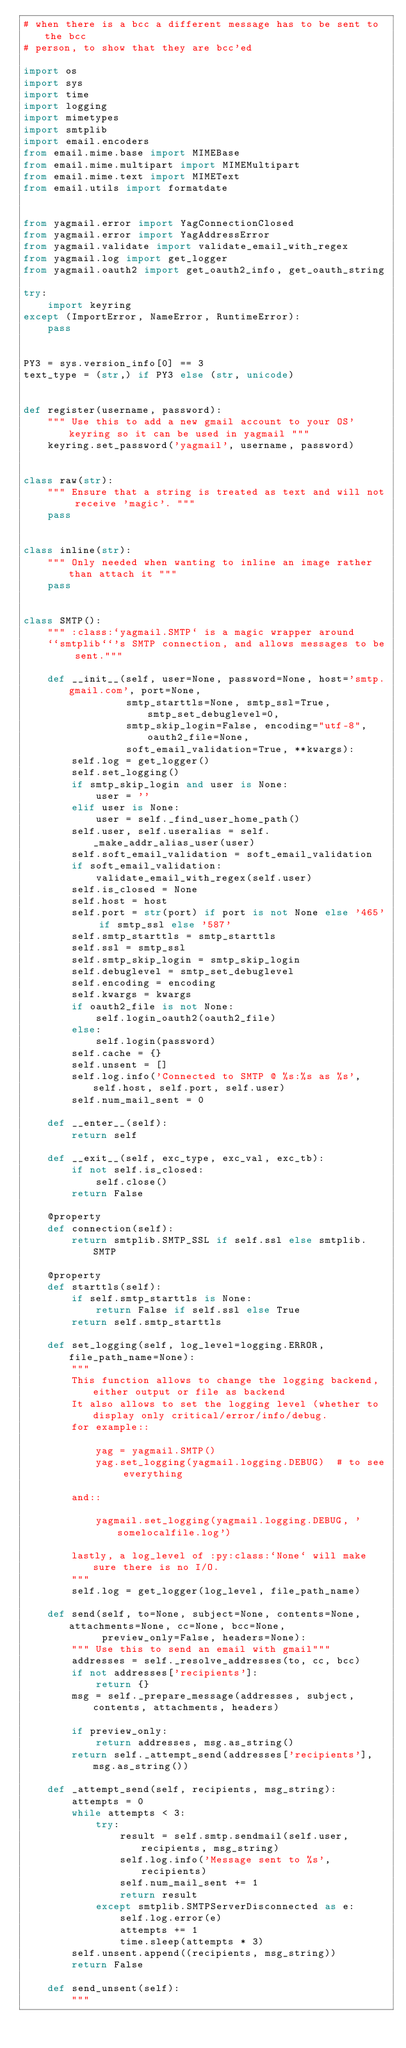Convert code to text. <code><loc_0><loc_0><loc_500><loc_500><_Python_># when there is a bcc a different message has to be sent to the bcc
# person, to show that they are bcc'ed

import os
import sys
import time
import logging
import mimetypes
import smtplib
import email.encoders
from email.mime.base import MIMEBase
from email.mime.multipart import MIMEMultipart
from email.mime.text import MIMEText
from email.utils import formatdate


from yagmail.error import YagConnectionClosed
from yagmail.error import YagAddressError
from yagmail.validate import validate_email_with_regex
from yagmail.log import get_logger
from yagmail.oauth2 import get_oauth2_info, get_oauth_string

try:
    import keyring
except (ImportError, NameError, RuntimeError):
    pass


PY3 = sys.version_info[0] == 3
text_type = (str,) if PY3 else (str, unicode)


def register(username, password):
    """ Use this to add a new gmail account to your OS' keyring so it can be used in yagmail """
    keyring.set_password('yagmail', username, password)


class raw(str):
    """ Ensure that a string is treated as text and will not receive 'magic'. """
    pass


class inline(str):
    """ Only needed when wanting to inline an image rather than attach it """
    pass


class SMTP():
    """ :class:`yagmail.SMTP` is a magic wrapper around
    ``smtplib``'s SMTP connection, and allows messages to be sent."""

    def __init__(self, user=None, password=None, host='smtp.gmail.com', port=None,
                 smtp_starttls=None, smtp_ssl=True, smtp_set_debuglevel=0,
                 smtp_skip_login=False, encoding="utf-8", oauth2_file=None,
                 soft_email_validation=True, **kwargs):
        self.log = get_logger()
        self.set_logging()
        if smtp_skip_login and user is None:
            user = ''
        elif user is None:
            user = self._find_user_home_path()
        self.user, self.useralias = self._make_addr_alias_user(user)
        self.soft_email_validation = soft_email_validation
        if soft_email_validation:
            validate_email_with_regex(self.user)
        self.is_closed = None
        self.host = host
        self.port = str(port) if port is not None else '465' if smtp_ssl else '587'
        self.smtp_starttls = smtp_starttls
        self.ssl = smtp_ssl
        self.smtp_skip_login = smtp_skip_login
        self.debuglevel = smtp_set_debuglevel
        self.encoding = encoding
        self.kwargs = kwargs
        if oauth2_file is not None:
            self.login_oauth2(oauth2_file)
        else:
            self.login(password)
        self.cache = {}
        self.unsent = []
        self.log.info('Connected to SMTP @ %s:%s as %s', self.host, self.port, self.user)
        self.num_mail_sent = 0

    def __enter__(self):
        return self

    def __exit__(self, exc_type, exc_val, exc_tb):
        if not self.is_closed:
            self.close()
        return False

    @property
    def connection(self):
        return smtplib.SMTP_SSL if self.ssl else smtplib.SMTP

    @property
    def starttls(self):
        if self.smtp_starttls is None:
            return False if self.ssl else True
        return self.smtp_starttls

    def set_logging(self, log_level=logging.ERROR, file_path_name=None):
        """
        This function allows to change the logging backend, either output or file as backend
        It also allows to set the logging level (whether to display only critical/error/info/debug.
        for example::

            yag = yagmail.SMTP()
            yag.set_logging(yagmail.logging.DEBUG)  # to see everything

        and::

            yagmail.set_logging(yagmail.logging.DEBUG, 'somelocalfile.log')

        lastly, a log_level of :py:class:`None` will make sure there is no I/O.
        """
        self.log = get_logger(log_level, file_path_name)

    def send(self, to=None, subject=None, contents=None, attachments=None, cc=None, bcc=None,
             preview_only=False, headers=None):
        """ Use this to send an email with gmail"""
        addresses = self._resolve_addresses(to, cc, bcc)
        if not addresses['recipients']:
            return {}
        msg = self._prepare_message(addresses, subject, contents, attachments, headers)

        if preview_only:
            return addresses, msg.as_string()
        return self._attempt_send(addresses['recipients'], msg.as_string())

    def _attempt_send(self, recipients, msg_string):
        attempts = 0
        while attempts < 3:
            try:
                result = self.smtp.sendmail(self.user, recipients, msg_string)
                self.log.info('Message sent to %s', recipients)
                self.num_mail_sent += 1
                return result
            except smtplib.SMTPServerDisconnected as e:
                self.log.error(e)
                attempts += 1
                time.sleep(attempts * 3)
        self.unsent.append((recipients, msg_string))
        return False

    def send_unsent(self):
        """</code> 